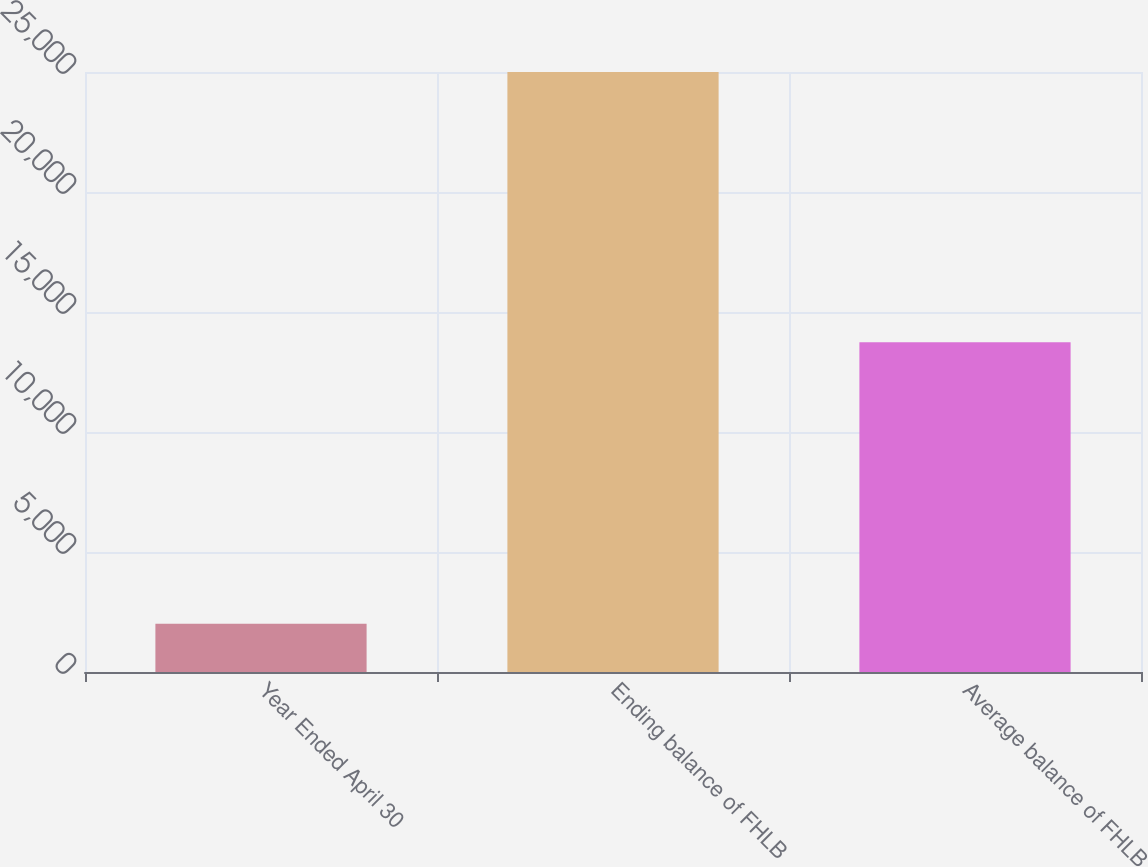Convert chart to OTSL. <chart><loc_0><loc_0><loc_500><loc_500><bar_chart><fcel>Year Ended April 30<fcel>Ending balance of FHLB<fcel>Average balance of FHLB<nl><fcel>2008<fcel>25000<fcel>13743<nl></chart> 